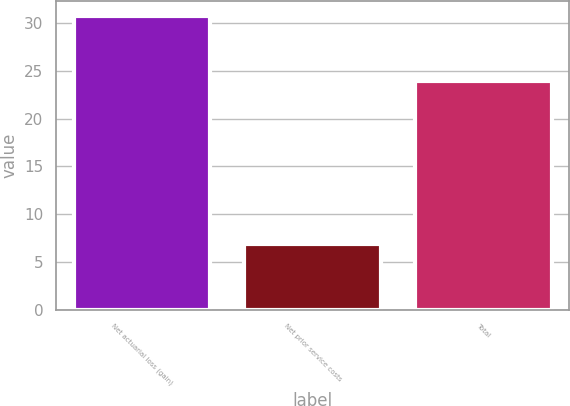Convert chart to OTSL. <chart><loc_0><loc_0><loc_500><loc_500><bar_chart><fcel>Net actuarial loss (gain)<fcel>Net prior service costs<fcel>Total<nl><fcel>30.8<fcel>6.9<fcel>23.9<nl></chart> 